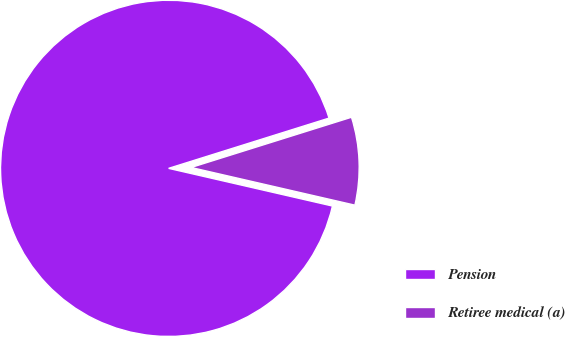Convert chart. <chart><loc_0><loc_0><loc_500><loc_500><pie_chart><fcel>Pension<fcel>Retiree medical (a)<nl><fcel>91.57%<fcel>8.43%<nl></chart> 